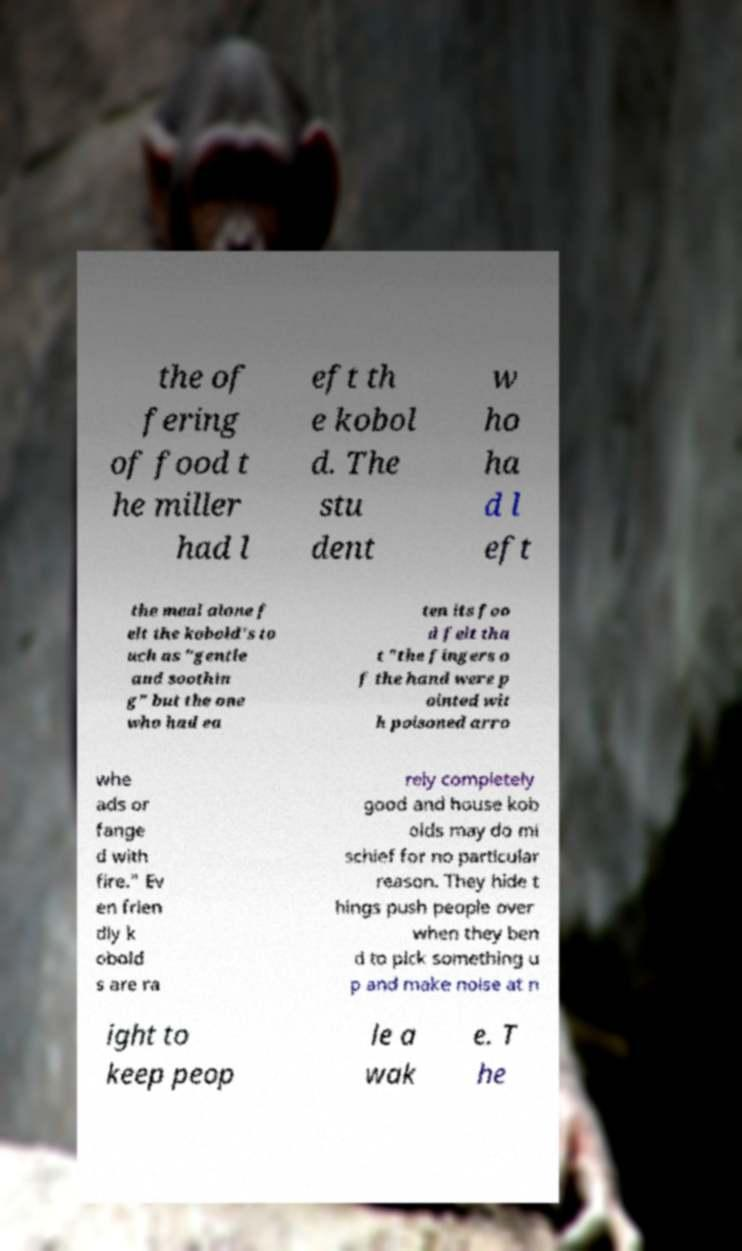Could you assist in decoding the text presented in this image and type it out clearly? the of fering of food t he miller had l eft th e kobol d. The stu dent w ho ha d l eft the meal alone f elt the kobold's to uch as "gentle and soothin g" but the one who had ea ten its foo d felt tha t "the fingers o f the hand were p ointed wit h poisoned arro whe ads or fange d with fire." Ev en frien dly k obold s are ra rely completely good and house kob olds may do mi schief for no particular reason. They hide t hings push people over when they ben d to pick something u p and make noise at n ight to keep peop le a wak e. T he 